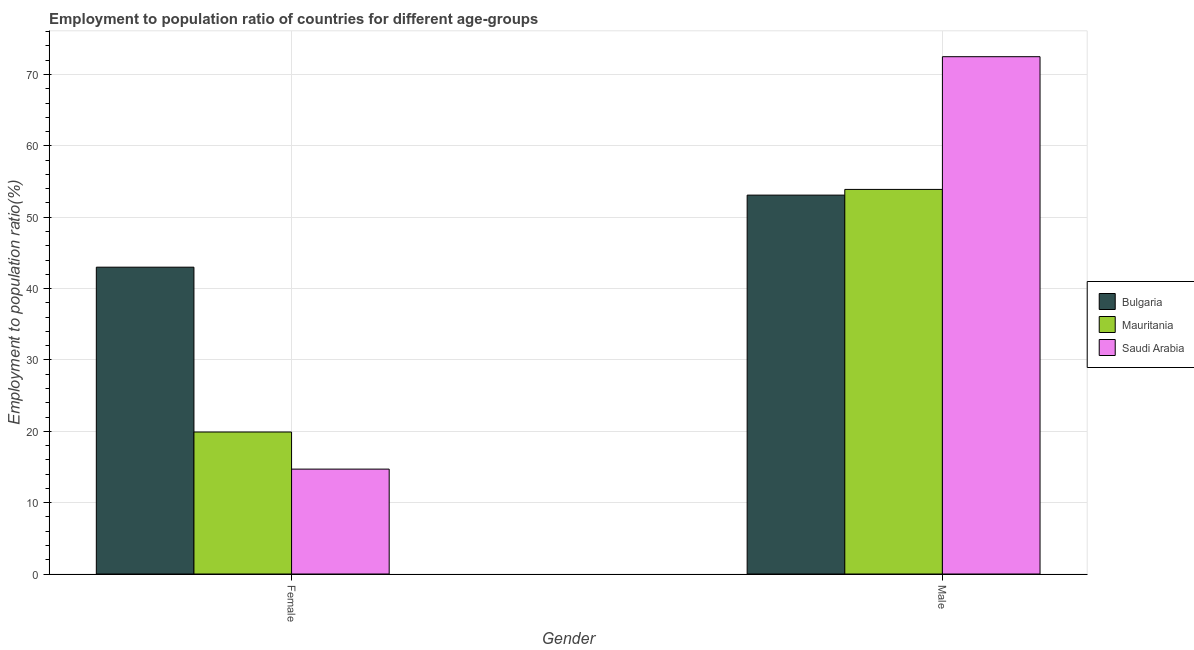How many different coloured bars are there?
Your answer should be compact. 3. How many bars are there on the 2nd tick from the left?
Keep it short and to the point. 3. What is the label of the 2nd group of bars from the left?
Give a very brief answer. Male. What is the employment to population ratio(female) in Bulgaria?
Give a very brief answer. 43. Across all countries, what is the minimum employment to population ratio(female)?
Keep it short and to the point. 14.7. In which country was the employment to population ratio(female) maximum?
Your answer should be compact. Bulgaria. In which country was the employment to population ratio(female) minimum?
Make the answer very short. Saudi Arabia. What is the total employment to population ratio(male) in the graph?
Provide a short and direct response. 179.5. What is the difference between the employment to population ratio(male) in Saudi Arabia and that in Bulgaria?
Give a very brief answer. 19.4. What is the difference between the employment to population ratio(female) in Bulgaria and the employment to population ratio(male) in Mauritania?
Give a very brief answer. -10.9. What is the average employment to population ratio(female) per country?
Make the answer very short. 25.87. What is the difference between the employment to population ratio(female) and employment to population ratio(male) in Bulgaria?
Provide a short and direct response. -10.1. What is the ratio of the employment to population ratio(female) in Mauritania to that in Saudi Arabia?
Make the answer very short. 1.35. Is the employment to population ratio(male) in Mauritania less than that in Bulgaria?
Provide a succinct answer. No. In how many countries, is the employment to population ratio(male) greater than the average employment to population ratio(male) taken over all countries?
Give a very brief answer. 1. What does the 1st bar from the left in Female represents?
Provide a succinct answer. Bulgaria. What is the difference between two consecutive major ticks on the Y-axis?
Your answer should be very brief. 10. Are the values on the major ticks of Y-axis written in scientific E-notation?
Your answer should be very brief. No. Does the graph contain grids?
Provide a succinct answer. Yes. How many legend labels are there?
Offer a very short reply. 3. What is the title of the graph?
Your answer should be compact. Employment to population ratio of countries for different age-groups. Does "Gabon" appear as one of the legend labels in the graph?
Offer a very short reply. No. What is the label or title of the X-axis?
Give a very brief answer. Gender. What is the label or title of the Y-axis?
Ensure brevity in your answer.  Employment to population ratio(%). What is the Employment to population ratio(%) of Mauritania in Female?
Ensure brevity in your answer.  19.9. What is the Employment to population ratio(%) in Saudi Arabia in Female?
Your answer should be very brief. 14.7. What is the Employment to population ratio(%) in Bulgaria in Male?
Ensure brevity in your answer.  53.1. What is the Employment to population ratio(%) in Mauritania in Male?
Give a very brief answer. 53.9. What is the Employment to population ratio(%) of Saudi Arabia in Male?
Provide a succinct answer. 72.5. Across all Gender, what is the maximum Employment to population ratio(%) in Bulgaria?
Offer a terse response. 53.1. Across all Gender, what is the maximum Employment to population ratio(%) in Mauritania?
Keep it short and to the point. 53.9. Across all Gender, what is the maximum Employment to population ratio(%) in Saudi Arabia?
Your answer should be compact. 72.5. Across all Gender, what is the minimum Employment to population ratio(%) in Bulgaria?
Provide a succinct answer. 43. Across all Gender, what is the minimum Employment to population ratio(%) in Mauritania?
Your response must be concise. 19.9. Across all Gender, what is the minimum Employment to population ratio(%) of Saudi Arabia?
Your answer should be compact. 14.7. What is the total Employment to population ratio(%) in Bulgaria in the graph?
Give a very brief answer. 96.1. What is the total Employment to population ratio(%) of Mauritania in the graph?
Provide a short and direct response. 73.8. What is the total Employment to population ratio(%) of Saudi Arabia in the graph?
Keep it short and to the point. 87.2. What is the difference between the Employment to population ratio(%) in Bulgaria in Female and that in Male?
Offer a very short reply. -10.1. What is the difference between the Employment to population ratio(%) of Mauritania in Female and that in Male?
Provide a short and direct response. -34. What is the difference between the Employment to population ratio(%) of Saudi Arabia in Female and that in Male?
Provide a short and direct response. -57.8. What is the difference between the Employment to population ratio(%) in Bulgaria in Female and the Employment to population ratio(%) in Mauritania in Male?
Your answer should be compact. -10.9. What is the difference between the Employment to population ratio(%) of Bulgaria in Female and the Employment to population ratio(%) of Saudi Arabia in Male?
Give a very brief answer. -29.5. What is the difference between the Employment to population ratio(%) in Mauritania in Female and the Employment to population ratio(%) in Saudi Arabia in Male?
Offer a terse response. -52.6. What is the average Employment to population ratio(%) of Bulgaria per Gender?
Provide a short and direct response. 48.05. What is the average Employment to population ratio(%) of Mauritania per Gender?
Make the answer very short. 36.9. What is the average Employment to population ratio(%) of Saudi Arabia per Gender?
Offer a very short reply. 43.6. What is the difference between the Employment to population ratio(%) in Bulgaria and Employment to population ratio(%) in Mauritania in Female?
Offer a very short reply. 23.1. What is the difference between the Employment to population ratio(%) of Bulgaria and Employment to population ratio(%) of Saudi Arabia in Female?
Give a very brief answer. 28.3. What is the difference between the Employment to population ratio(%) of Bulgaria and Employment to population ratio(%) of Mauritania in Male?
Provide a short and direct response. -0.8. What is the difference between the Employment to population ratio(%) of Bulgaria and Employment to population ratio(%) of Saudi Arabia in Male?
Your answer should be compact. -19.4. What is the difference between the Employment to population ratio(%) in Mauritania and Employment to population ratio(%) in Saudi Arabia in Male?
Make the answer very short. -18.6. What is the ratio of the Employment to population ratio(%) of Bulgaria in Female to that in Male?
Provide a succinct answer. 0.81. What is the ratio of the Employment to population ratio(%) in Mauritania in Female to that in Male?
Ensure brevity in your answer.  0.37. What is the ratio of the Employment to population ratio(%) of Saudi Arabia in Female to that in Male?
Keep it short and to the point. 0.2. What is the difference between the highest and the second highest Employment to population ratio(%) of Mauritania?
Offer a terse response. 34. What is the difference between the highest and the second highest Employment to population ratio(%) in Saudi Arabia?
Offer a terse response. 57.8. What is the difference between the highest and the lowest Employment to population ratio(%) in Saudi Arabia?
Provide a succinct answer. 57.8. 